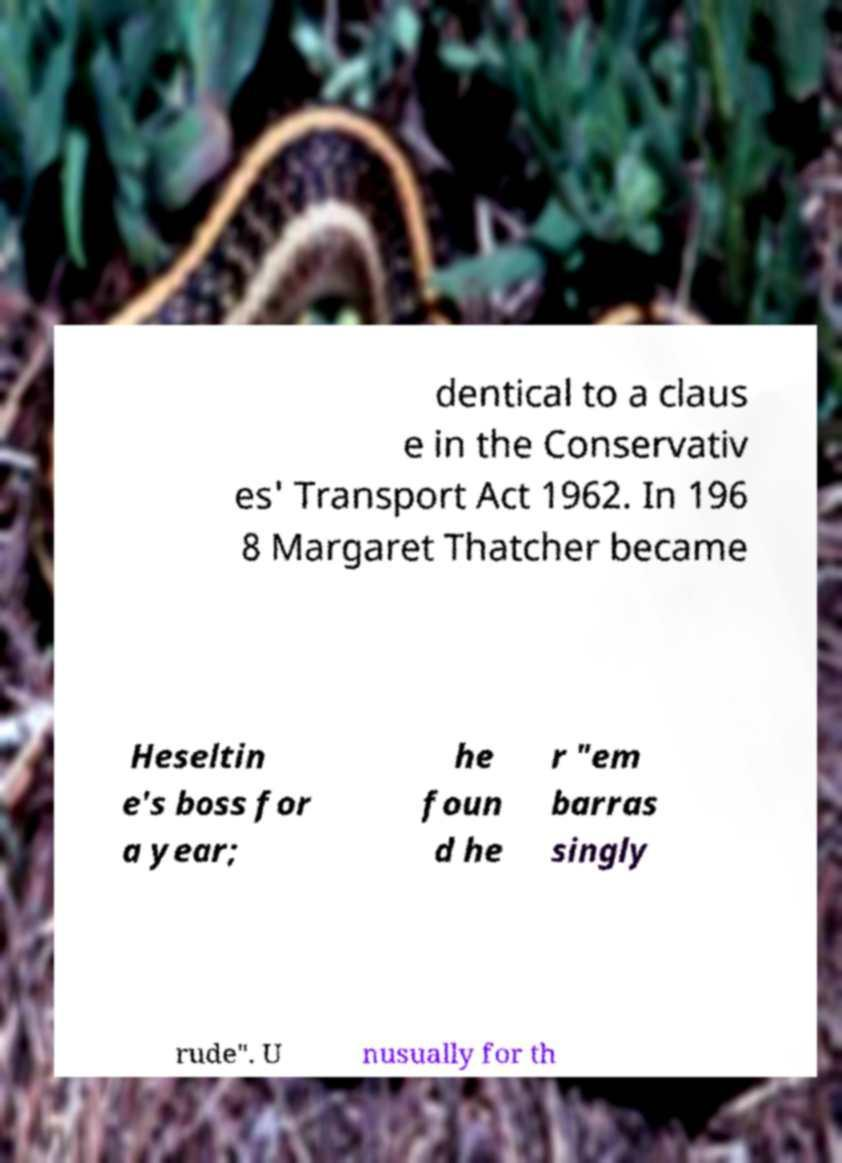Please identify and transcribe the text found in this image. dentical to a claus e in the Conservativ es' Transport Act 1962. In 196 8 Margaret Thatcher became Heseltin e's boss for a year; he foun d he r "em barras singly rude". U nusually for th 